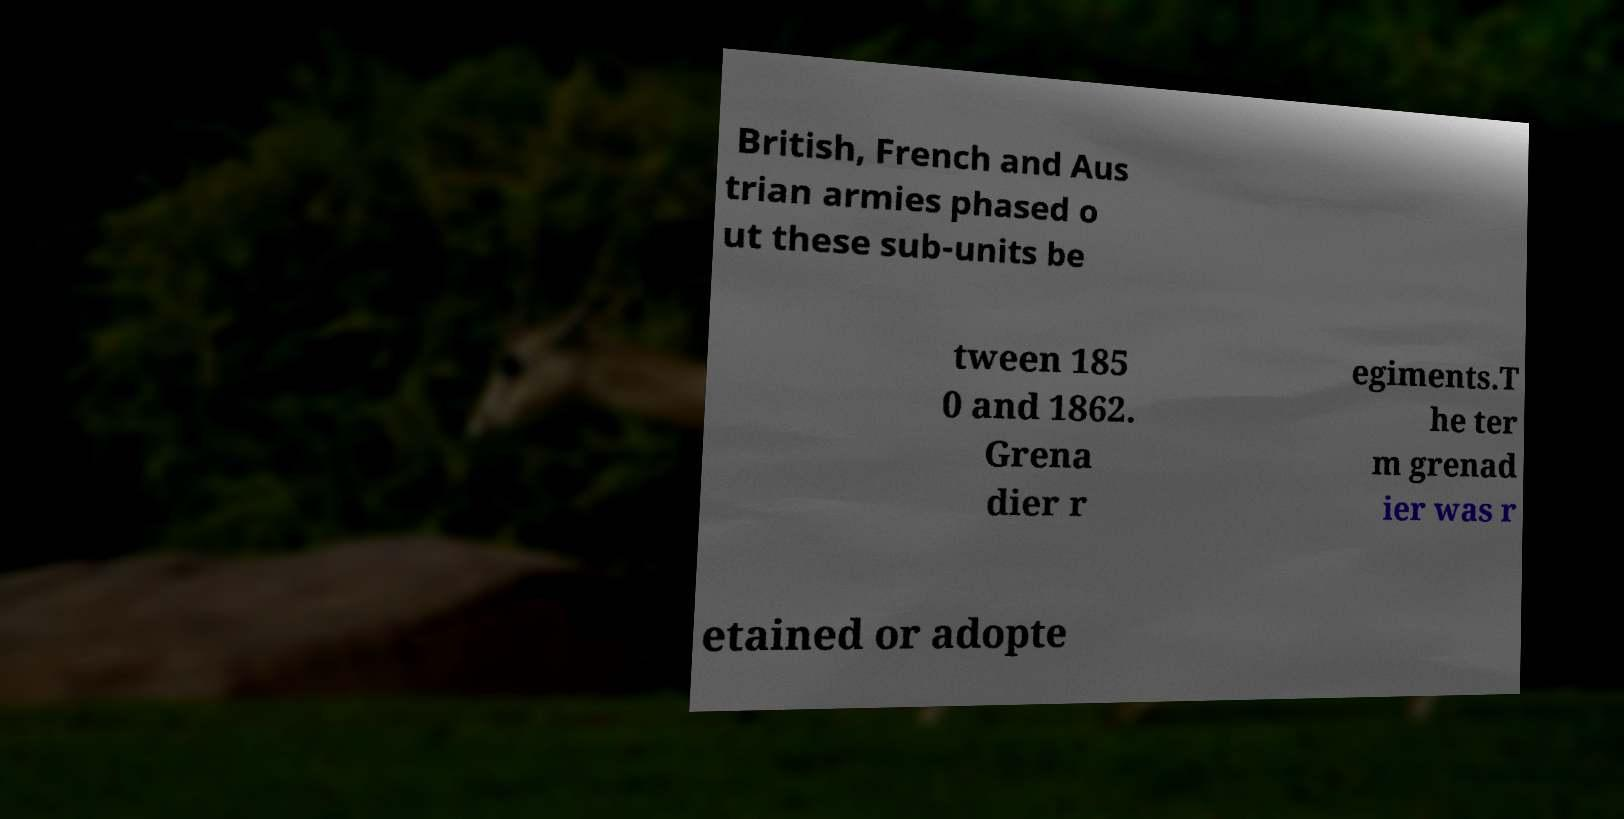Can you read and provide the text displayed in the image?This photo seems to have some interesting text. Can you extract and type it out for me? British, French and Aus trian armies phased o ut these sub-units be tween 185 0 and 1862. Grena dier r egiments.T he ter m grenad ier was r etained or adopte 